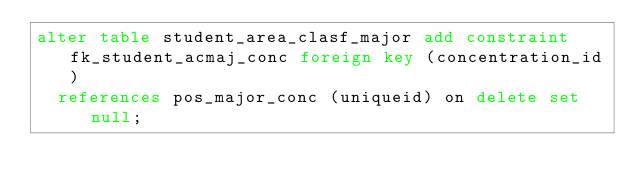<code> <loc_0><loc_0><loc_500><loc_500><_SQL_>alter table student_area_clasf_major add constraint fk_student_acmaj_conc foreign key (concentration_id)
	references pos_major_conc (uniqueid) on delete set null;
</code> 